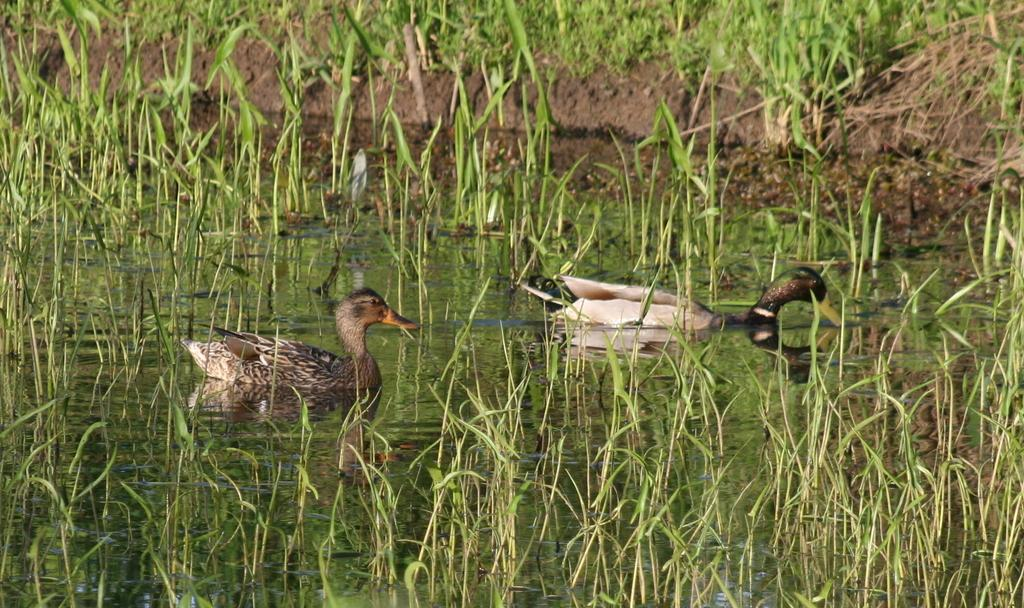What animals are in the middle of the image? There are two ducks in the middle of the image. What type of terrain is visible in the image? There is grass, plants, and water in the image. Where are the plants located in the image? There are plants in the image, and some are at the top of the image. What is the composition of the land at the top of the image? There is land at the top of the image, and it has plants on it. What type of cabbage is being harvested in the image? There is no cabbage present in the image; it features two ducks in a grassy, plant-filled environment with water. 